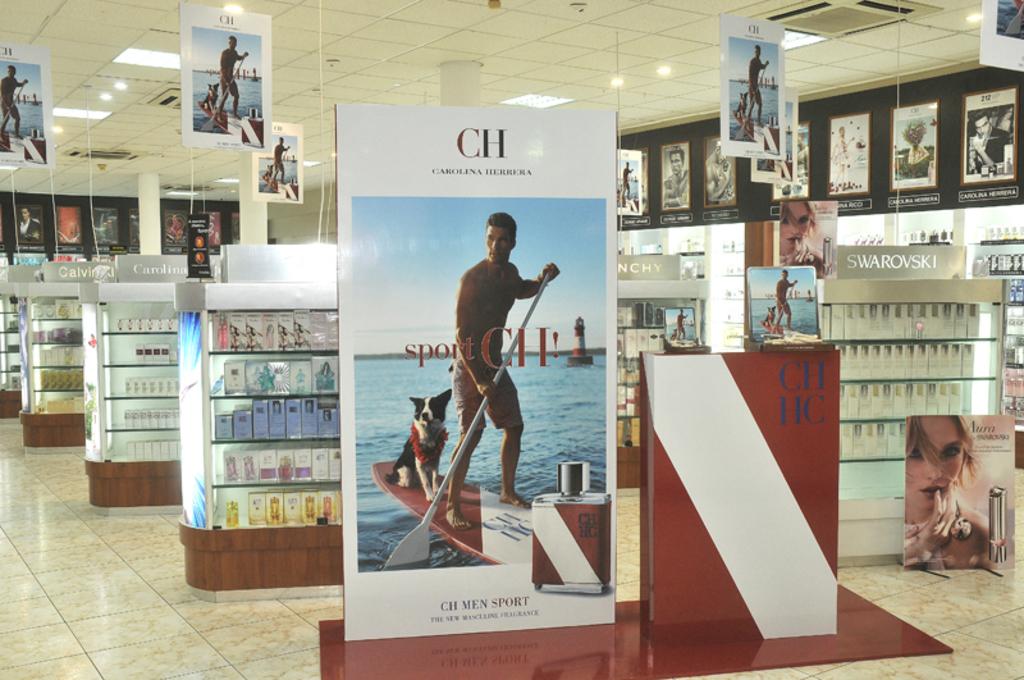What company is adverised on the main display?
Your answer should be compact. Ch. What brand is on the grey sign furthest to the right?
Your response must be concise. Swarovski. 